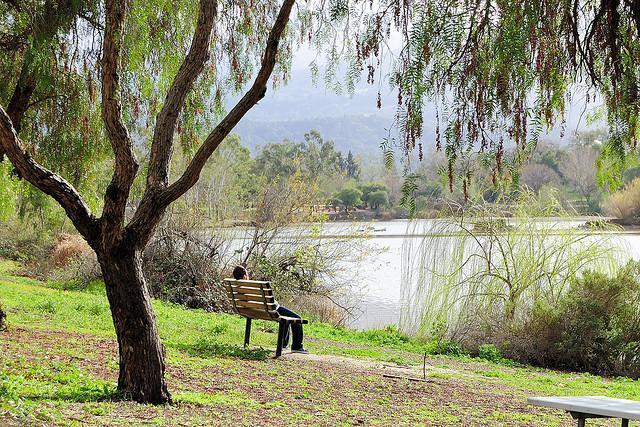How many tree trunks are in the picture?
Give a very brief answer. 1. How many trees are there?
Give a very brief answer. 1. 